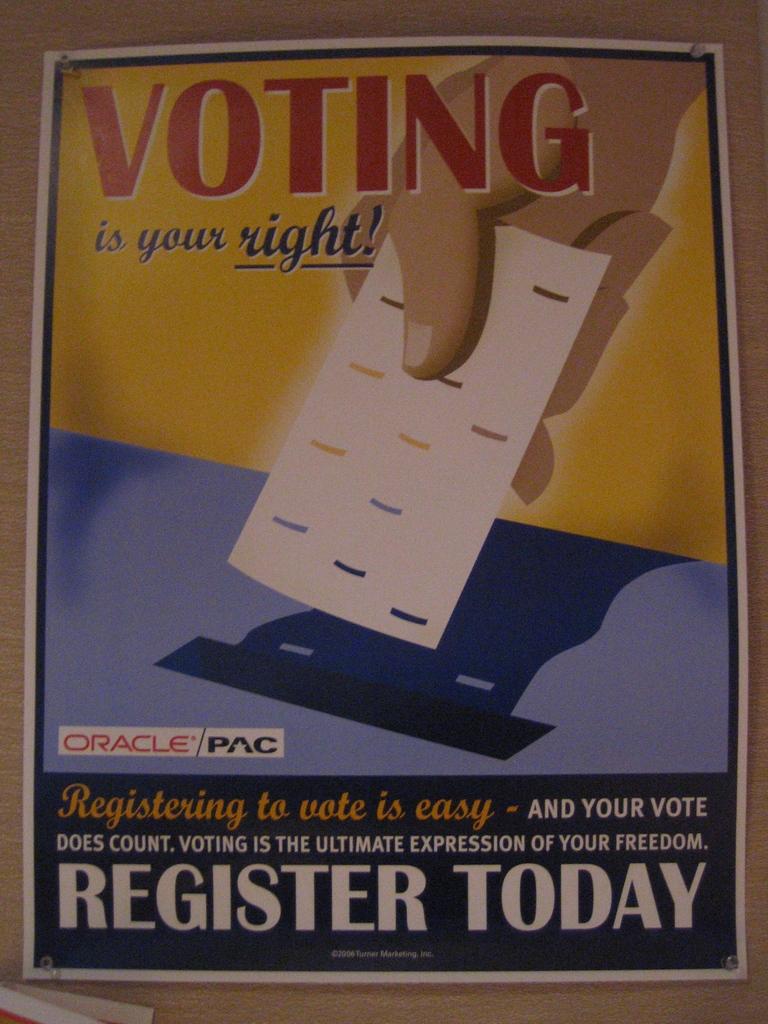What is your right?
Provide a succinct answer. Voting. When should you register?
Your answer should be compact. Today. 